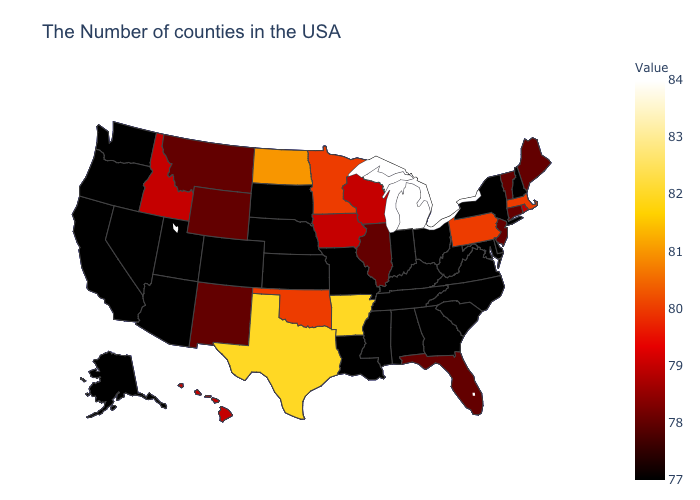Is the legend a continuous bar?
Concise answer only. Yes. Does Rhode Island have the lowest value in the Northeast?
Keep it brief. No. Among the states that border Georgia , which have the lowest value?
Give a very brief answer. North Carolina, South Carolina, Alabama, Tennessee. Which states have the highest value in the USA?
Be succinct. Michigan. Does Texas have the highest value in the South?
Write a very short answer. Yes. Does Arkansas have the highest value in the USA?
Concise answer only. No. Among the states that border Idaho , does Oregon have the lowest value?
Be succinct. Yes. 